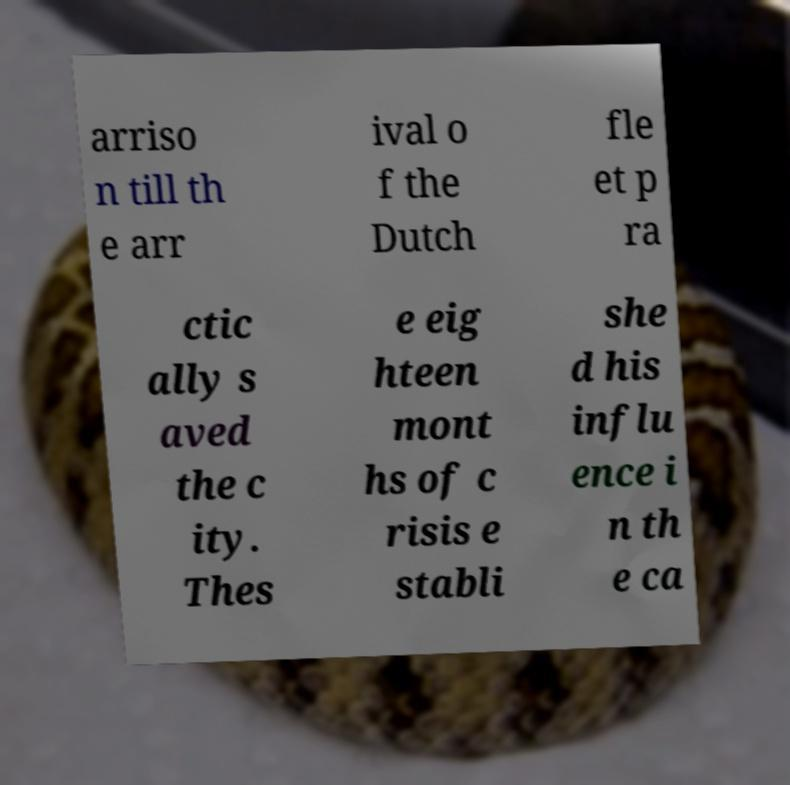What messages or text are displayed in this image? I need them in a readable, typed format. arriso n till th e arr ival o f the Dutch fle et p ra ctic ally s aved the c ity. Thes e eig hteen mont hs of c risis e stabli she d his influ ence i n th e ca 